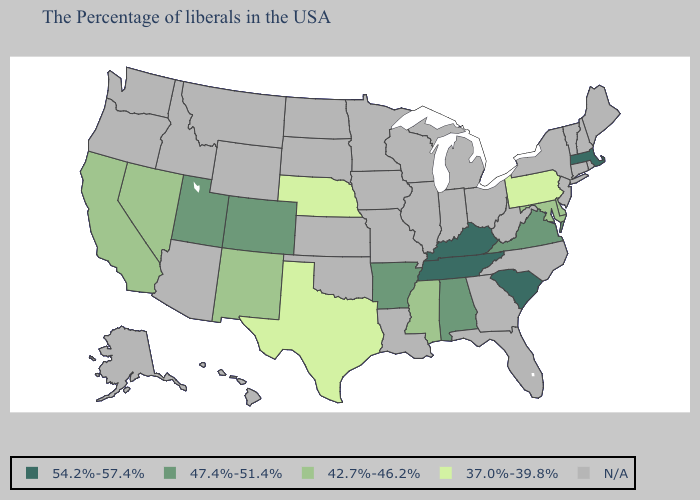Does Pennsylvania have the highest value in the Northeast?
Be succinct. No. What is the lowest value in the USA?
Be succinct. 37.0%-39.8%. Name the states that have a value in the range N/A?
Short answer required. Maine, Rhode Island, New Hampshire, Vermont, Connecticut, New York, New Jersey, North Carolina, West Virginia, Ohio, Florida, Georgia, Michigan, Indiana, Wisconsin, Illinois, Louisiana, Missouri, Minnesota, Iowa, Kansas, Oklahoma, South Dakota, North Dakota, Wyoming, Montana, Arizona, Idaho, Washington, Oregon, Alaska, Hawaii. What is the highest value in the USA?
Short answer required. 54.2%-57.4%. What is the value of Tennessee?
Keep it brief. 54.2%-57.4%. Which states hav the highest value in the South?
Concise answer only. South Carolina, Kentucky, Tennessee. Does Texas have the lowest value in the South?
Short answer required. Yes. Name the states that have a value in the range 47.4%-51.4%?
Keep it brief. Virginia, Alabama, Arkansas, Colorado, Utah. Which states have the lowest value in the South?
Give a very brief answer. Texas. What is the value of Alaska?
Answer briefly. N/A. Does Delaware have the highest value in the USA?
Be succinct. No. Is the legend a continuous bar?
Keep it brief. No. Does Massachusetts have the lowest value in the USA?
Short answer required. No. Name the states that have a value in the range 47.4%-51.4%?
Be succinct. Virginia, Alabama, Arkansas, Colorado, Utah. 